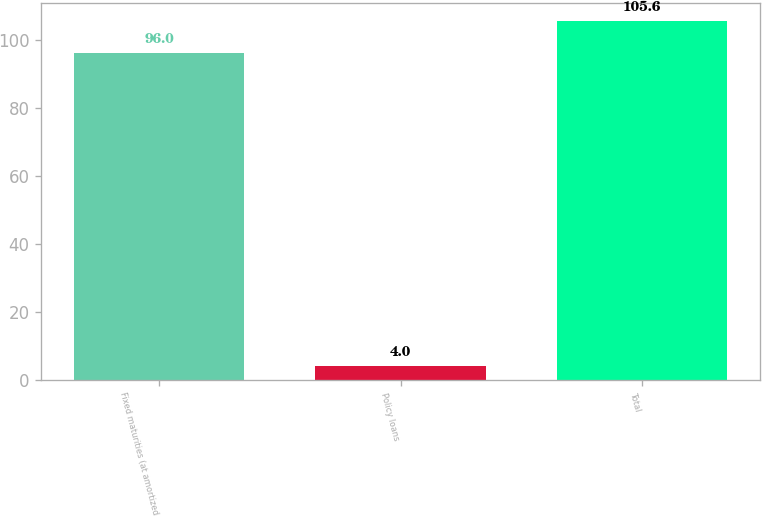<chart> <loc_0><loc_0><loc_500><loc_500><bar_chart><fcel>Fixed maturities (at amortized<fcel>Policy loans<fcel>Total<nl><fcel>96<fcel>4<fcel>105.6<nl></chart> 